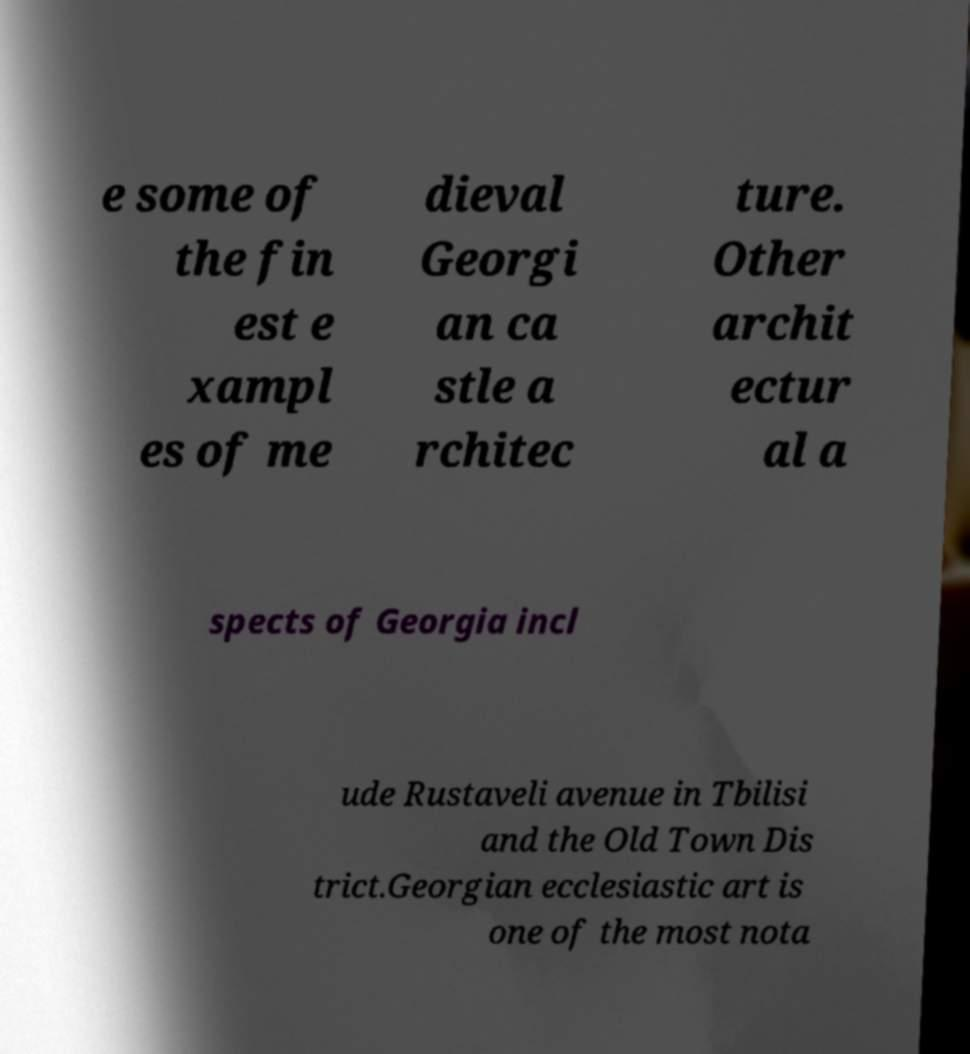Could you assist in decoding the text presented in this image and type it out clearly? e some of the fin est e xampl es of me dieval Georgi an ca stle a rchitec ture. Other archit ectur al a spects of Georgia incl ude Rustaveli avenue in Tbilisi and the Old Town Dis trict.Georgian ecclesiastic art is one of the most nota 